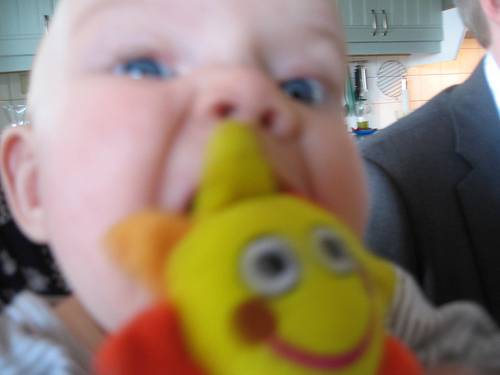<image>
Can you confirm if the wall is behind the cabinet? Yes. From this viewpoint, the wall is positioned behind the cabinet, with the cabinet partially or fully occluding the wall. Is the baby to the right of the toy? No. The baby is not to the right of the toy. The horizontal positioning shows a different relationship. Is there a doll in front of the baby? Yes. The doll is positioned in front of the baby, appearing closer to the camera viewpoint. 